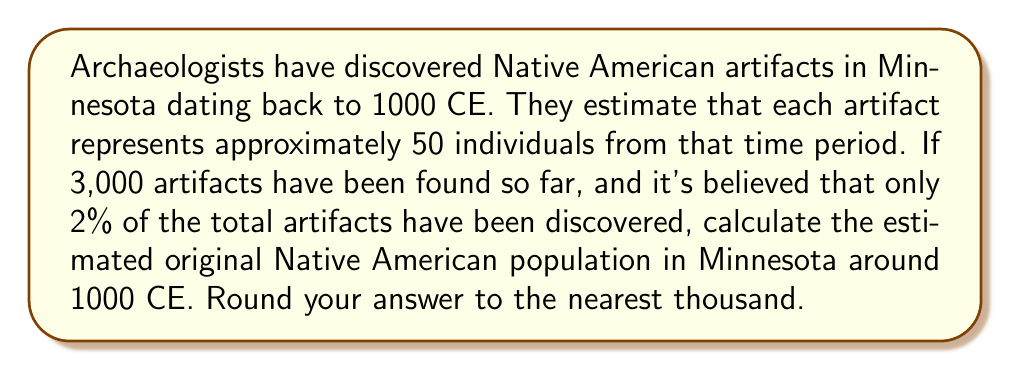Solve this math problem. Let's approach this step-by-step:

1) First, we need to determine how many people are represented by the artifacts found:
   $$ 3,000 \text{ artifacts} \times 50 \text{ people/artifact} = 150,000 \text{ people} $$

2) However, this only represents 2% of the total population. To find the total, we need to set up an equation:
   $$ 150,000 = 0.02x $$
   Where $x$ is the total population we're trying to find.

3) To solve for $x$, we divide both sides by 0.02:
   $$ x = \frac{150,000}{0.02} = 7,500,000 $$

4) Rounding to the nearest thousand:
   $$ 7,500,000 \approx 7,500,000 $$

This calculation suggests that the original Native American population in Minnesota around 1000 CE was approximately 7,500,000 people.
Answer: 7,500,000 